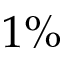<formula> <loc_0><loc_0><loc_500><loc_500>1 \%</formula> 